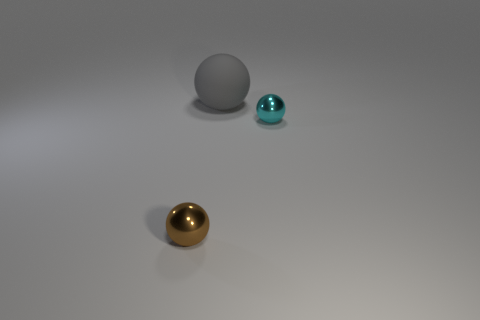Add 2 cyan matte cubes. How many objects exist? 5 Subtract all yellow matte cubes. Subtract all big objects. How many objects are left? 2 Add 1 small things. How many small things are left? 3 Add 3 shiny spheres. How many shiny spheres exist? 5 Subtract 0 red spheres. How many objects are left? 3 